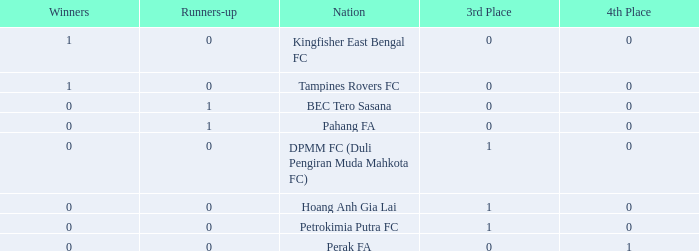Name the highest 3rd place for nation of perak fa 0.0. 